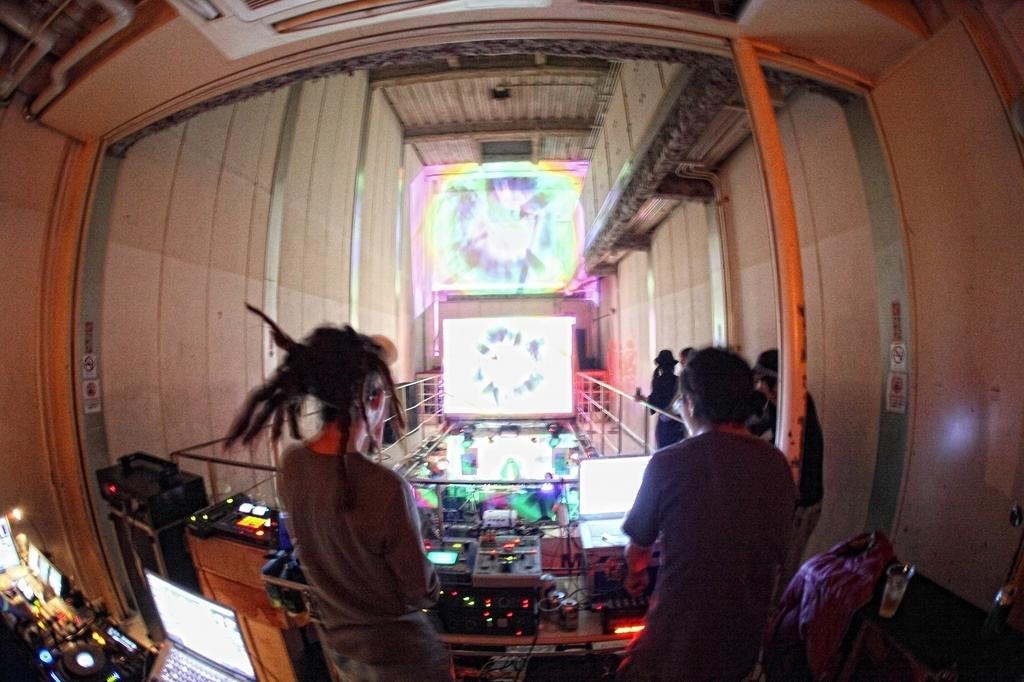How many people are in the image? There are people in the image, but the exact number is not specified. What electronic devices can be seen in the image? There are laptops in the image. What type of musical instruments are present in the image? There are musical instruments in the image. What connects the devices or instruments in the image? Cables are present in the image. What other objects can be seen in the image besides the people, laptops, and musical instruments? There are other objects in the image, but their specific nature is not mentioned. What architectural feature is visible in the image? There is a grille in the image. What type of surface is visible in the image? There is a wall in the image. What displays information or media in the image? There are screens in the image. What type of leg is visible in the image? There is no leg visible in the image. What type of bedroom is shown in the image? The image does not depict a bedroom; it contains people, laptops, musical instruments, cables, other objects, a grille, a wall, and screens. 